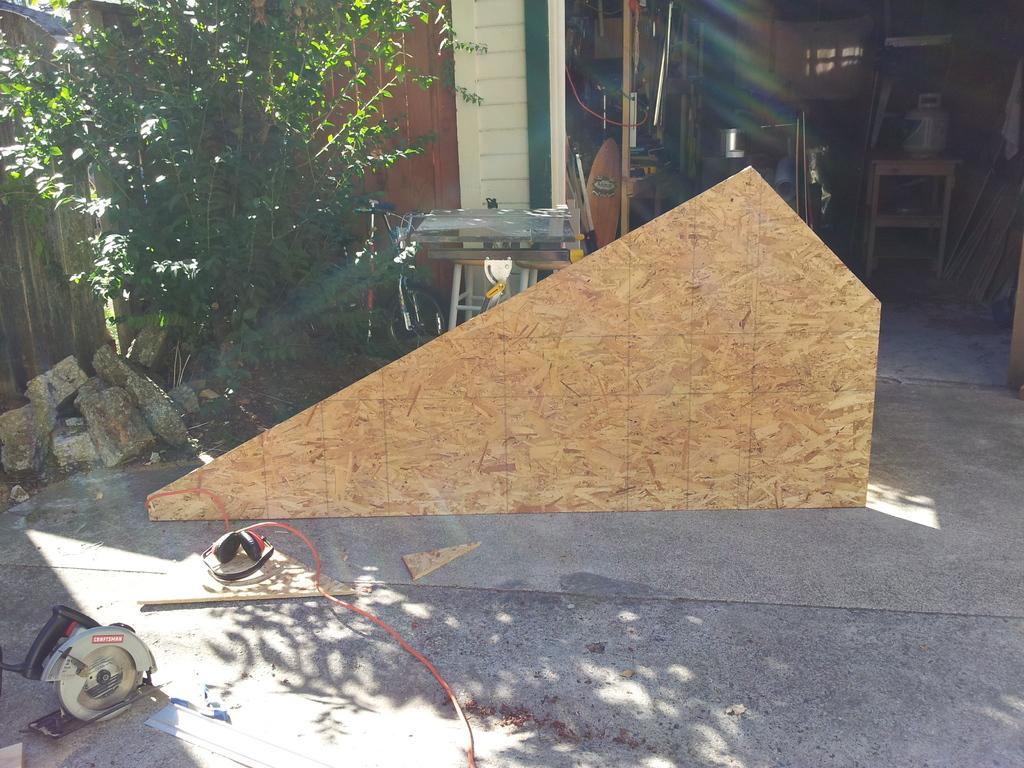What is the surface on which the machines and wooden plank are placed in the image? There is a floor in the image. What types of objects are on the floor? There are machines and a wooden plank on the floor. What can be seen in the background of the image? There is a plant and a shed in the background of the image. What is inside the shed? There are objects inside the shed. What type of discovery is being made inside the tent in the image? There is no tent present in the image; it only a floor, machines, a wooden plank, a plant, a shed, and objects inside the shed are visible. How old is the baby in the image? There is no baby present in the image. 